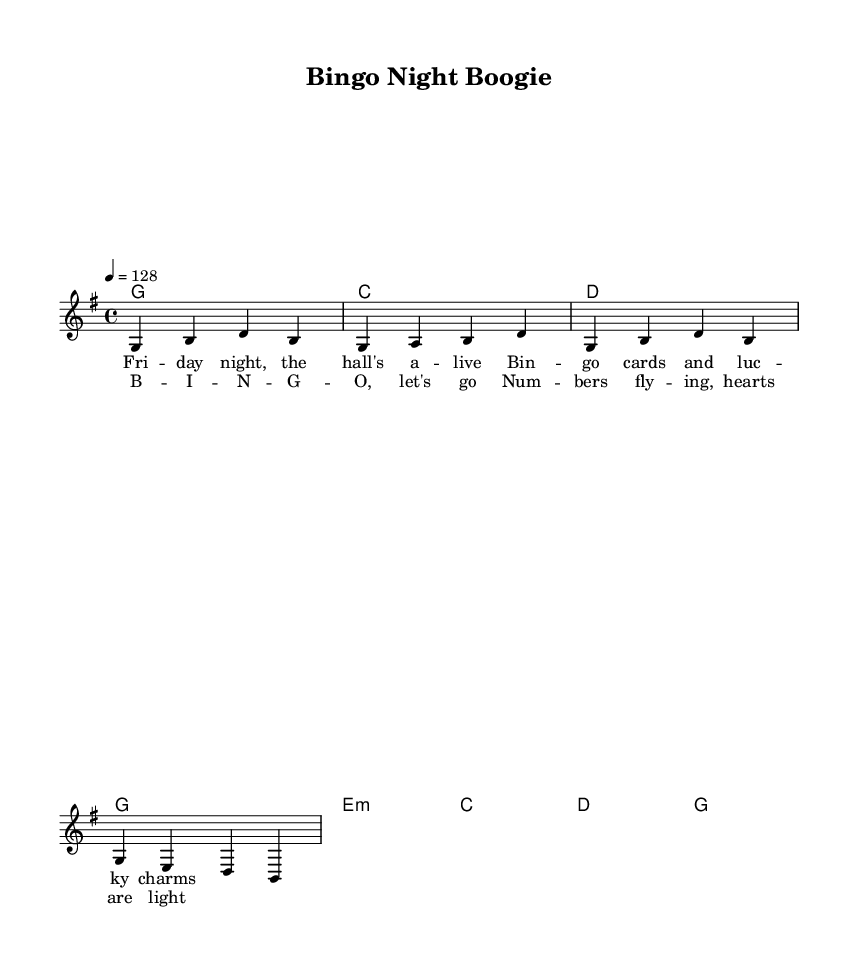What is the key signature of this music? The key signature appears next to the clef at the beginning of the staff. In this case, it shows one sharp, indicating that the key is G major.
Answer: G major What is the time signature of this music? The time signature is found near the beginning of the music, shown as a fraction. Here, the time signature is 4/4, which means there are four beats in each measure.
Answer: 4/4 What is the tempo marking for this music? The tempo marking is indicated at the top of the score. The marking shows "4 = 128", which means the quarter note should be played at a speed of 128 beats per minute.
Answer: 128 How many measures are in the first verse? To find the number of measures in the verse, we count how many times a vertical line (the bar line) appears in the verse section. In this case, there are four measures.
Answer: 4 What is the main theme of the lyrics in the chorus? By reading the lyrics in the chorus, we can see that it talks about excitement and numbers involved in the bingo game. The main theme centers around the enjoyment and joy found in playing bingo.
Answer: Bingo excitement What type of harmony is used in the chord section? The type of harmony listed in the chord section shows a combination of major and minor chords. The chords like G and C are major, while E minor is indicated with a lower case 'm', showing a mixture of both types of harmony.
Answer: Major and minor What is the overall mood conveyed by the music style? The music style combines upbeat tempos typical in country rock with cheerful lyrics about social gatherings, indicating a joyful and lively atmosphere suitable for community gatherings.
Answer: Joyful 